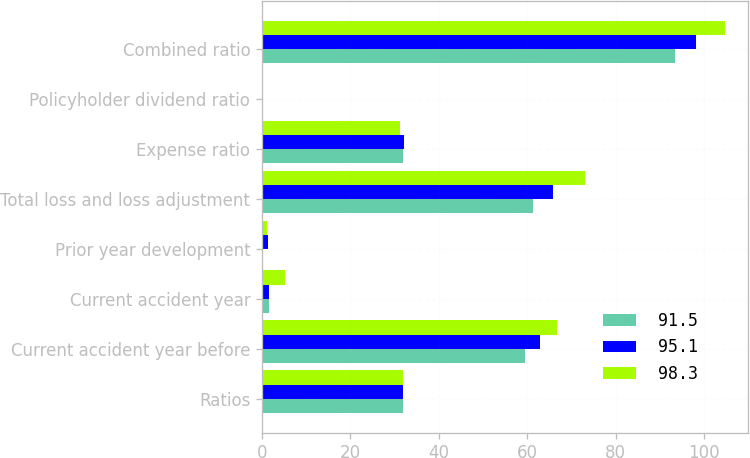Convert chart to OTSL. <chart><loc_0><loc_0><loc_500><loc_500><stacked_bar_chart><ecel><fcel>Ratios<fcel>Current accident year before<fcel>Current accident year<fcel>Prior year development<fcel>Total loss and loss adjustment<fcel>Expense ratio<fcel>Policyholder dividend ratio<fcel>Combined ratio<nl><fcel>91.5<fcel>31.9<fcel>59.4<fcel>1.7<fcel>0.2<fcel>61.3<fcel>31.9<fcel>0.2<fcel>93.4<nl><fcel>95.1<fcel>31.9<fcel>62.8<fcel>1.7<fcel>1.3<fcel>65.9<fcel>32<fcel>0.3<fcel>98.1<nl><fcel>98.3<fcel>31.9<fcel>66.8<fcel>5.2<fcel>1.2<fcel>73.1<fcel>31.3<fcel>0.2<fcel>104.6<nl></chart> 